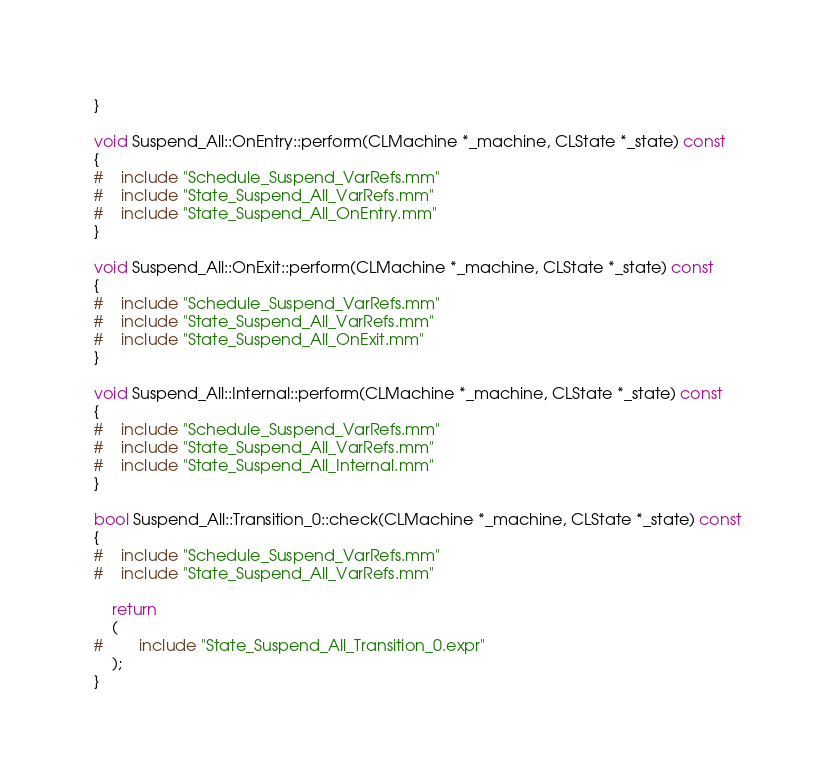Convert code to text. <code><loc_0><loc_0><loc_500><loc_500><_ObjectiveC_>}

void Suspend_All::OnEntry::perform(CLMachine *_machine, CLState *_state) const
{
#	include "Schedule_Suspend_VarRefs.mm"
#	include "State_Suspend_All_VarRefs.mm"
#	include "State_Suspend_All_OnEntry.mm"
}

void Suspend_All::OnExit::perform(CLMachine *_machine, CLState *_state) const
{
#	include "Schedule_Suspend_VarRefs.mm"
#	include "State_Suspend_All_VarRefs.mm"
#	include "State_Suspend_All_OnExit.mm"
}

void Suspend_All::Internal::perform(CLMachine *_machine, CLState *_state) const
{
#	include "Schedule_Suspend_VarRefs.mm"
#	include "State_Suspend_All_VarRefs.mm"
#	include "State_Suspend_All_Internal.mm"
}

bool Suspend_All::Transition_0::check(CLMachine *_machine, CLState *_state) const
{
#	include "Schedule_Suspend_VarRefs.mm"
#	include "State_Suspend_All_VarRefs.mm"

	return
	(
#		include "State_Suspend_All_Transition_0.expr"
	);
}
</code> 